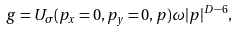Convert formula to latex. <formula><loc_0><loc_0><loc_500><loc_500>g = U _ { \sigma } ( p _ { x } = 0 , p _ { y } = 0 , { p } ) \omega | { p } | ^ { D - 6 } ,</formula> 